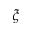Convert formula to latex. <formula><loc_0><loc_0><loc_500><loc_500>\xi</formula> 